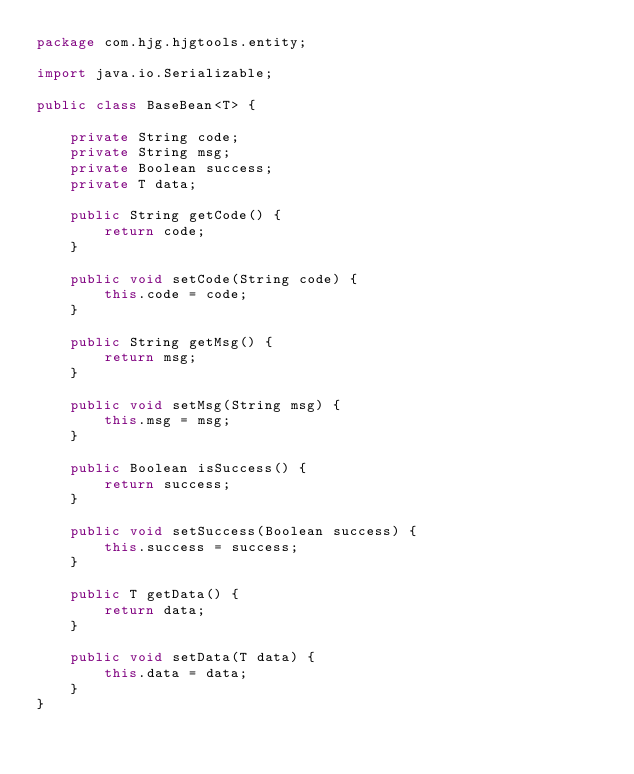<code> <loc_0><loc_0><loc_500><loc_500><_Java_>package com.hjg.hjgtools.entity;

import java.io.Serializable;

public class BaseBean<T> {

    private String code;
    private String msg;
    private Boolean success;
    private T data;

    public String getCode() {
        return code;
    }

    public void setCode(String code) {
        this.code = code;
    }

    public String getMsg() {
        return msg;
    }

    public void setMsg(String msg) {
        this.msg = msg;
    }

    public Boolean isSuccess() {
        return success;
    }

    public void setSuccess(Boolean success) {
        this.success = success;
    }

    public T getData() {
        return data;
    }

    public void setData(T data) {
        this.data = data;
    }
}
</code> 